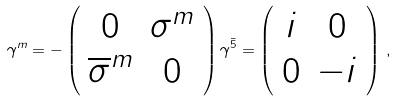<formula> <loc_0><loc_0><loc_500><loc_500>\gamma ^ { m } = - \left ( \begin{array} { c c } 0 & \sigma ^ { m } \\ \overline { \sigma } ^ { m } & 0 \end{array} \right ) \gamma ^ { \bar { 5 } } = \left ( \begin{array} { c c } i & 0 \\ 0 & - i \end{array} \right ) \, ,</formula> 